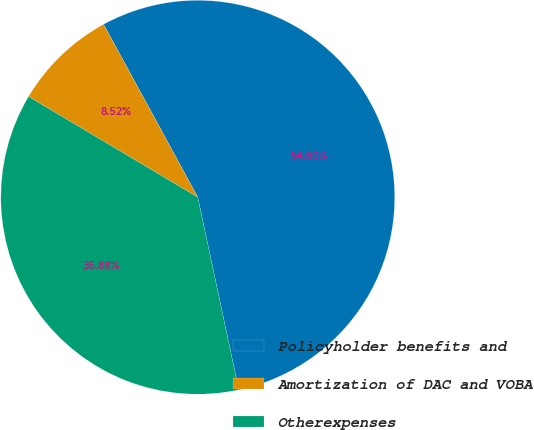<chart> <loc_0><loc_0><loc_500><loc_500><pie_chart><fcel>Policyholder benefits and<fcel>Amortization of DAC and VOBA<fcel>Otherexpenses<nl><fcel>54.6%<fcel>8.52%<fcel>36.88%<nl></chart> 